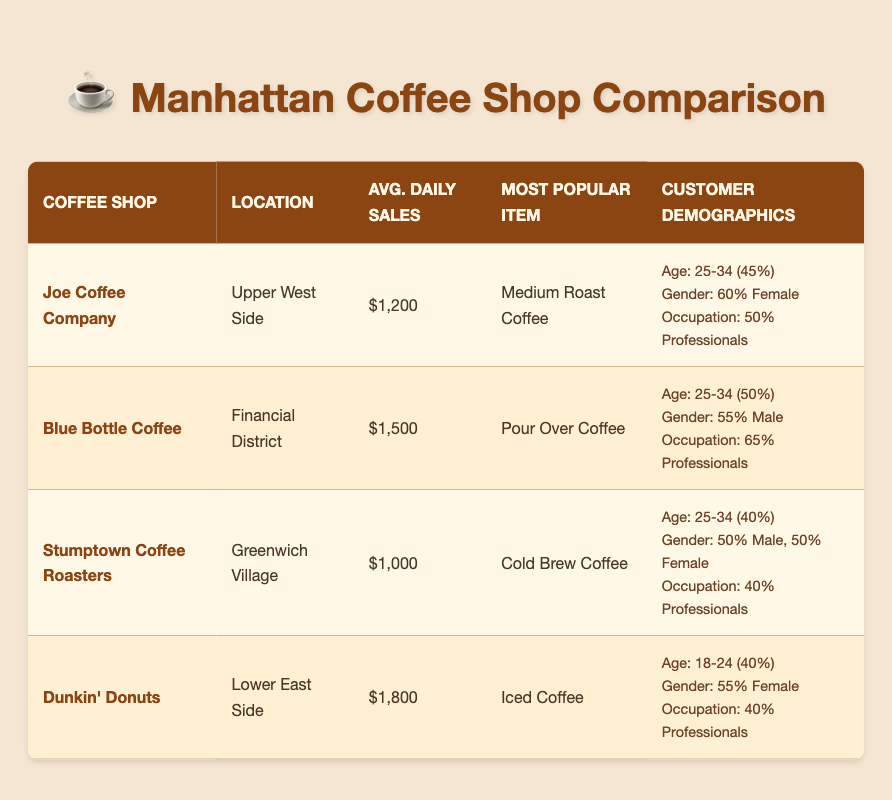What's the average daily sales of Dunkin' Donuts? The table indicates that Dunkin' Donuts has average daily sales of $1,800.
Answer: $1,800 Which coffee shop has the highest average daily sales? By looking at the average daily sales column, Dunkin' Donuts has the highest sales at $1,800, compared to the others.
Answer: Dunkin' Donuts Are there more female customers than male customers at Joe Coffee Company? In Joe Coffee Company, female customers are 60%, while male customers are 40%. Since 60% is greater than 40%, the answer is yes.
Answer: Yes What is the most popular menu item at Stumptown Coffee Roasters? According to the table, the most popular menu item at Stumptown Coffee Roasters is Cold Brew Coffee.
Answer: Cold Brew Coffee How many professionals are customers at Blue Bottle Coffee compared to the total number of customers? The total customer demographic is determined through the age group counts (20 + 50 + 20 + 10 = 100). Blue Bottle Coffee has 65 professionals, so the percentage of professionals is (65/100) * 100 = 65%.
Answer: 65% What is the age group that makes up the largest percentage of customers at Dunkin' Donuts? The customer demographic shows that the largest age group is 18-24, comprising 40% of the customer base at Dunkin' Donuts.
Answer: 18-24 How does the customer demographic of age group 25-34 at Joe Coffee Company compare to that at Stumptown Coffee Roasters? Joe Coffee Company has 45% in the age group 25-34, while Stumptown Coffee Roasters has 40%. Joe Coffee Company's percentage is higher.
Answer: Joe Coffee Company has a higher percentage Is the most popular menu item at Blue Bottle Coffee different from that at Joe Coffee Company? Blue Bottle Coffee's most popular menu item is Pour Over Coffee, while Joe Coffee Company's is Medium Roast Coffee. Since these two items are different, the answer is yes.
Answer: Yes What is the percentage of male and female customers at Stumptown Coffee Roasters? The table states that Stumptown Coffee Roasters has an equal percentage of male and female customers, with both at 50% each.
Answer: 50% male, 50% female 